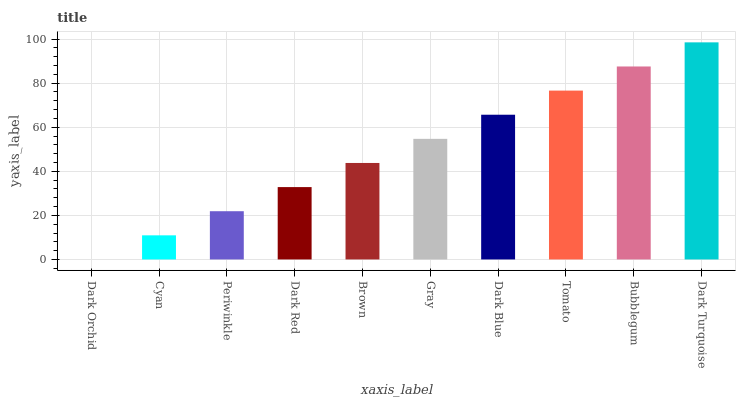Is Dark Orchid the minimum?
Answer yes or no. Yes. Is Dark Turquoise the maximum?
Answer yes or no. Yes. Is Cyan the minimum?
Answer yes or no. No. Is Cyan the maximum?
Answer yes or no. No. Is Cyan greater than Dark Orchid?
Answer yes or no. Yes. Is Dark Orchid less than Cyan?
Answer yes or no. Yes. Is Dark Orchid greater than Cyan?
Answer yes or no. No. Is Cyan less than Dark Orchid?
Answer yes or no. No. Is Gray the high median?
Answer yes or no. Yes. Is Brown the low median?
Answer yes or no. Yes. Is Dark Orchid the high median?
Answer yes or no. No. Is Dark Blue the low median?
Answer yes or no. No. 